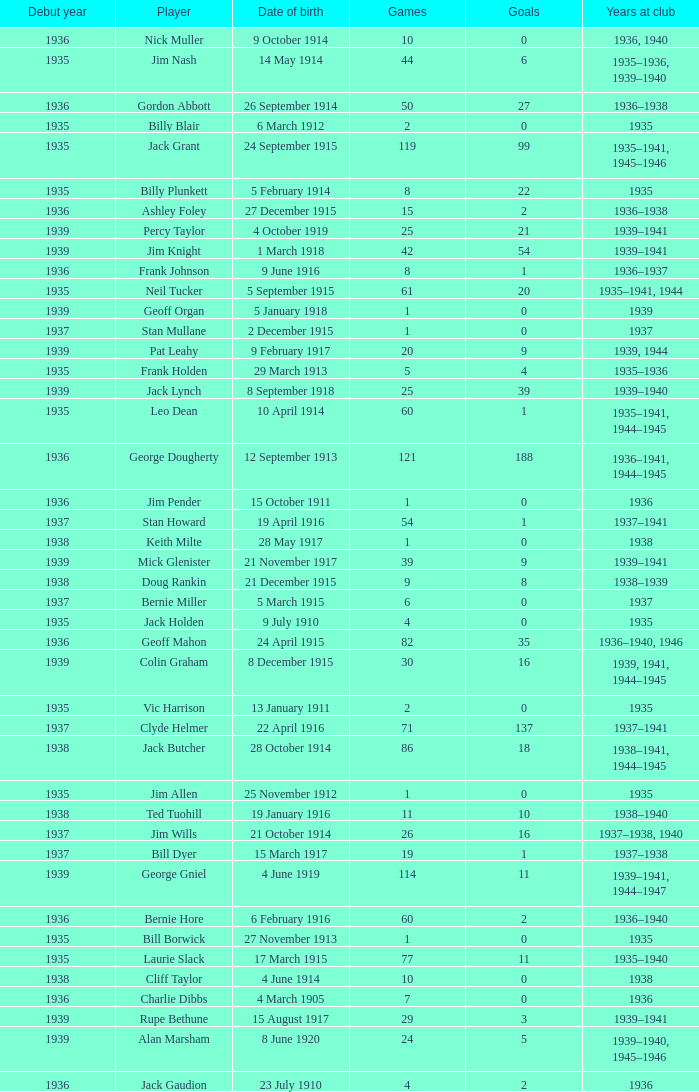What is the length of time at the club for the player who scored 2 goals and was born on 23 july 1910? 1936.0. 